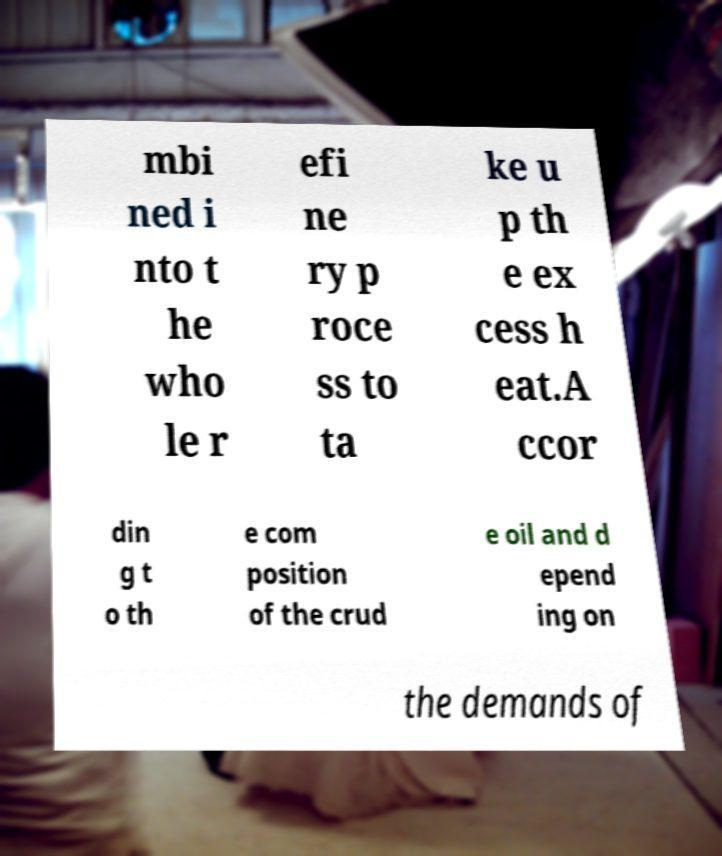Can you accurately transcribe the text from the provided image for me? mbi ned i nto t he who le r efi ne ry p roce ss to ta ke u p th e ex cess h eat.A ccor din g t o th e com position of the crud e oil and d epend ing on the demands of 